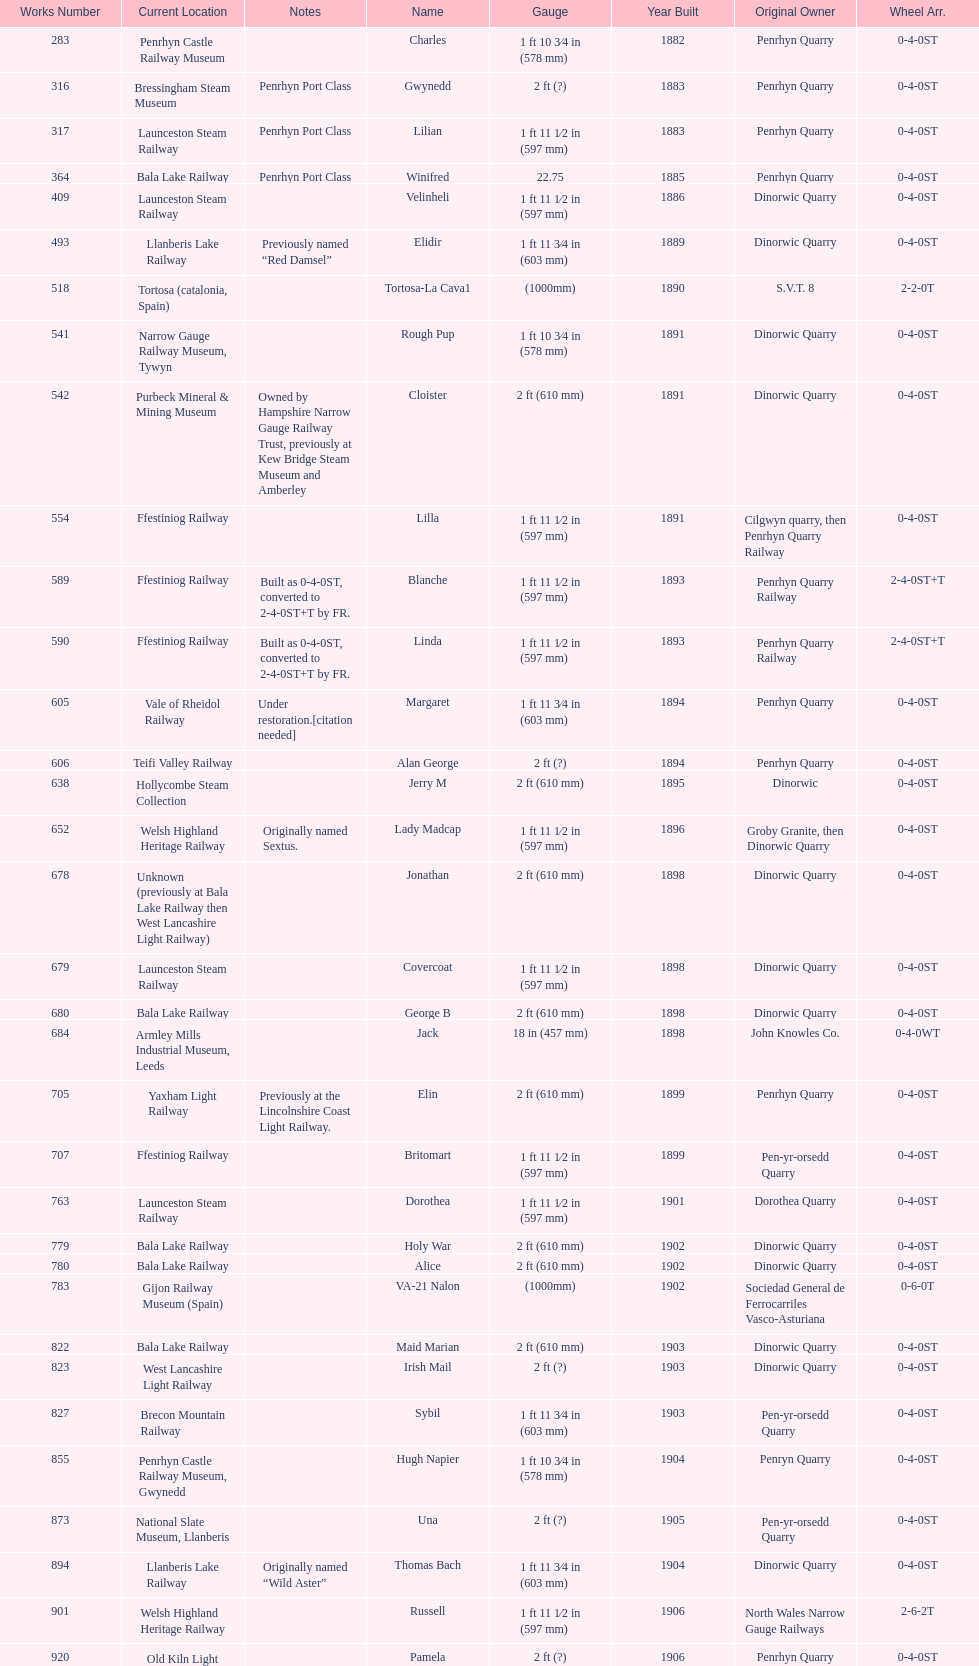Give me the full table as a dictionary. {'header': ['Works Number', 'Current Location', 'Notes', 'Name', 'Gauge', 'Year Built', 'Original Owner', 'Wheel Arr.'], 'rows': [['283', 'Penrhyn Castle Railway Museum', '', 'Charles', '1\xa0ft 10\xa03⁄4\xa0in (578\xa0mm)', '1882', 'Penrhyn Quarry', '0-4-0ST'], ['316', 'Bressingham Steam Museum', 'Penrhyn Port Class', 'Gwynedd', '2\xa0ft (?)', '1883', 'Penrhyn Quarry', '0-4-0ST'], ['317', 'Launceston Steam Railway', 'Penrhyn Port Class', 'Lilian', '1\xa0ft 11\xa01⁄2\xa0in (597\xa0mm)', '1883', 'Penrhyn Quarry', '0-4-0ST'], ['364', 'Bala Lake Railway', 'Penrhyn Port Class', 'Winifred', '22.75', '1885', 'Penrhyn Quarry', '0-4-0ST'], ['409', 'Launceston Steam Railway', '', 'Velinheli', '1\xa0ft 11\xa01⁄2\xa0in (597\xa0mm)', '1886', 'Dinorwic Quarry', '0-4-0ST'], ['493', 'Llanberis Lake Railway', 'Previously named “Red Damsel”', 'Elidir', '1\xa0ft 11\xa03⁄4\xa0in (603\xa0mm)', '1889', 'Dinorwic Quarry', '0-4-0ST'], ['518', 'Tortosa (catalonia, Spain)', '', 'Tortosa-La Cava1', '(1000mm)', '1890', 'S.V.T. 8', '2-2-0T'], ['541', 'Narrow Gauge Railway Museum, Tywyn', '', 'Rough Pup', '1\xa0ft 10\xa03⁄4\xa0in (578\xa0mm)', '1891', 'Dinorwic Quarry', '0-4-0ST'], ['542', 'Purbeck Mineral & Mining Museum', 'Owned by Hampshire Narrow Gauge Railway Trust, previously at Kew Bridge Steam Museum and Amberley', 'Cloister', '2\xa0ft (610\xa0mm)', '1891', 'Dinorwic Quarry', '0-4-0ST'], ['554', 'Ffestiniog Railway', '', 'Lilla', '1\xa0ft 11\xa01⁄2\xa0in (597\xa0mm)', '1891', 'Cilgwyn quarry, then Penrhyn Quarry Railway', '0-4-0ST'], ['589', 'Ffestiniog Railway', 'Built as 0-4-0ST, converted to 2-4-0ST+T by FR.', 'Blanche', '1\xa0ft 11\xa01⁄2\xa0in (597\xa0mm)', '1893', 'Penrhyn Quarry Railway', '2-4-0ST+T'], ['590', 'Ffestiniog Railway', 'Built as 0-4-0ST, converted to 2-4-0ST+T by FR.', 'Linda', '1\xa0ft 11\xa01⁄2\xa0in (597\xa0mm)', '1893', 'Penrhyn Quarry Railway', '2-4-0ST+T'], ['605', 'Vale of Rheidol Railway', 'Under restoration.[citation needed]', 'Margaret', '1\xa0ft 11\xa03⁄4\xa0in (603\xa0mm)', '1894', 'Penrhyn Quarry', '0-4-0ST'], ['606', 'Teifi Valley Railway', '', 'Alan George', '2\xa0ft (?)', '1894', 'Penrhyn Quarry', '0-4-0ST'], ['638', 'Hollycombe Steam Collection', '', 'Jerry M', '2\xa0ft (610\xa0mm)', '1895', 'Dinorwic', '0-4-0ST'], ['652', 'Welsh Highland Heritage Railway', 'Originally named Sextus.', 'Lady Madcap', '1\xa0ft 11\xa01⁄2\xa0in (597\xa0mm)', '1896', 'Groby Granite, then Dinorwic Quarry', '0-4-0ST'], ['678', 'Unknown (previously at Bala Lake Railway then West Lancashire Light Railway)', '', 'Jonathan', '2\xa0ft (610\xa0mm)', '1898', 'Dinorwic Quarry', '0-4-0ST'], ['679', 'Launceston Steam Railway', '', 'Covercoat', '1\xa0ft 11\xa01⁄2\xa0in (597\xa0mm)', '1898', 'Dinorwic Quarry', '0-4-0ST'], ['680', 'Bala Lake Railway', '', 'George B', '2\xa0ft (610\xa0mm)', '1898', 'Dinorwic Quarry', '0-4-0ST'], ['684', 'Armley Mills Industrial Museum, Leeds', '', 'Jack', '18\xa0in (457\xa0mm)', '1898', 'John Knowles Co.', '0-4-0WT'], ['705', 'Yaxham Light Railway', 'Previously at the Lincolnshire Coast Light Railway.', 'Elin', '2\xa0ft (610\xa0mm)', '1899', 'Penrhyn Quarry', '0-4-0ST'], ['707', 'Ffestiniog Railway', '', 'Britomart', '1\xa0ft 11\xa01⁄2\xa0in (597\xa0mm)', '1899', 'Pen-yr-orsedd Quarry', '0-4-0ST'], ['763', 'Launceston Steam Railway', '', 'Dorothea', '1\xa0ft 11\xa01⁄2\xa0in (597\xa0mm)', '1901', 'Dorothea Quarry', '0-4-0ST'], ['779', 'Bala Lake Railway', '', 'Holy War', '2\xa0ft (610\xa0mm)', '1902', 'Dinorwic Quarry', '0-4-0ST'], ['780', 'Bala Lake Railway', '', 'Alice', '2\xa0ft (610\xa0mm)', '1902', 'Dinorwic Quarry', '0-4-0ST'], ['783', 'Gijon Railway Museum (Spain)', '', 'VA-21 Nalon', '(1000mm)', '1902', 'Sociedad General de Ferrocarriles Vasco-Asturiana', '0-6-0T'], ['822', 'Bala Lake Railway', '', 'Maid Marian', '2\xa0ft (610\xa0mm)', '1903', 'Dinorwic Quarry', '0-4-0ST'], ['823', 'West Lancashire Light Railway', '', 'Irish Mail', '2\xa0ft (?)', '1903', 'Dinorwic Quarry', '0-4-0ST'], ['827', 'Brecon Mountain Railway', '', 'Sybil', '1\xa0ft 11\xa03⁄4\xa0in (603\xa0mm)', '1903', 'Pen-yr-orsedd Quarry', '0-4-0ST'], ['855', 'Penrhyn Castle Railway Museum, Gwynedd', '', 'Hugh Napier', '1\xa0ft 10\xa03⁄4\xa0in (578\xa0mm)', '1904', 'Penryn Quarry', '0-4-0ST'], ['873', 'National Slate Museum, Llanberis', '', 'Una', '2\xa0ft (?)', '1905', 'Pen-yr-orsedd Quarry', '0-4-0ST'], ['894', 'Llanberis Lake Railway', 'Originally named “Wild Aster”', 'Thomas Bach', '1\xa0ft 11\xa03⁄4\xa0in (603\xa0mm)', '1904', 'Dinorwic Quarry', '0-4-0ST'], ['901', 'Welsh Highland Heritage Railway', '', 'Russell', '1\xa0ft 11\xa01⁄2\xa0in (597\xa0mm)', '1906', 'North Wales Narrow Gauge Railways', '2-6-2T'], ['920', 'Old Kiln Light Railway', '', 'Pamela', '2\xa0ft (?)', '1906', 'Penrhyn Quarry', '0-4-0ST'], ['994', 'Bressingham Steam Museum', 'previously George Sholto', 'Bill Harvey', '2\xa0ft (?)', '1909', 'Penrhyn Quarry', '0-4-0ST'], ['1312', 'Pampas Safari, Gravataí, RS, Brazil', '[citation needed]', '---', '1\xa0ft\xa011\xa01⁄2\xa0in (597\xa0mm)', '1918', 'British War Department\\nEFOP #203', '4-6-0T'], ['1313', 'Usina Laginha, União dos Palmares, AL, Brazil', '[citation needed]', '---', '3\xa0ft\xa03\xa03⁄8\xa0in (1,000\xa0mm)', '1918\\nor\\n1921?', 'British War Department\\nUsina Leão Utinga #1\\nUsina Laginha #1', '0-6-2T'], ['1404', 'Richard Farmer current owner, Northridge, California, USA', '', 'Gwen', '18\xa0in (457\xa0mm)', '1920', 'John Knowles Co.', '0-4-0WT'], ['1429', 'Bredgar and Wormshill Light Railway', '', 'Lady Joan', '2\xa0ft (610\xa0mm)', '1922', 'Dinorwic', '0-4-0ST'], ['1430', 'Llanberis Lake Railway', '', 'Dolbadarn', '1\xa0ft 11\xa03⁄4\xa0in (603\xa0mm)', '1922', 'Dinorwic Quarry', '0-4-0ST'], ['1859', 'South Tynedale Railway', '', '16 Carlisle', '2\xa0ft (?)', '1937', 'Umtwalumi Valley Estate, Natal', '0-4-2T'], ['2075', 'North Gloucestershire Railway', '', 'Chaka’s Kraal No. 6', '2\xa0ft (?)', '1940', 'Chaka’s Kraal Sugar Estates, Natal', '0-4-2T'], ['3815', 'Welshpool and Llanfair Light Railway', '', '14', '2\xa0ft 6\xa0in (762\xa0mm)', '1954', 'Sierra Leone Government Railway', '2-6-2T'], ['3902', 'Statfold Barn Railway', 'Converted from 750\xa0mm (2\xa0ft\xa05\xa01⁄2\xa0in) gauge. Last steam locomotive to be built by Hunslet, and the last industrial steam locomotive built in Britain.', 'Trangkil No.4', '2\xa0ft (610\xa0mm)', '1971', 'Trangkil Sugar Mill, Indonesia', '0-4-2ST']]} After 1940, how many steam locomotives were built? 2. 